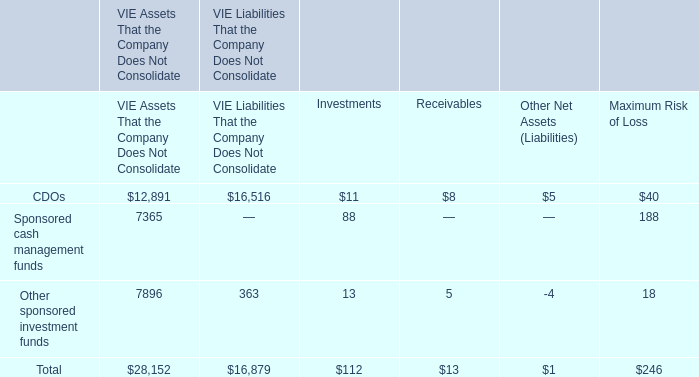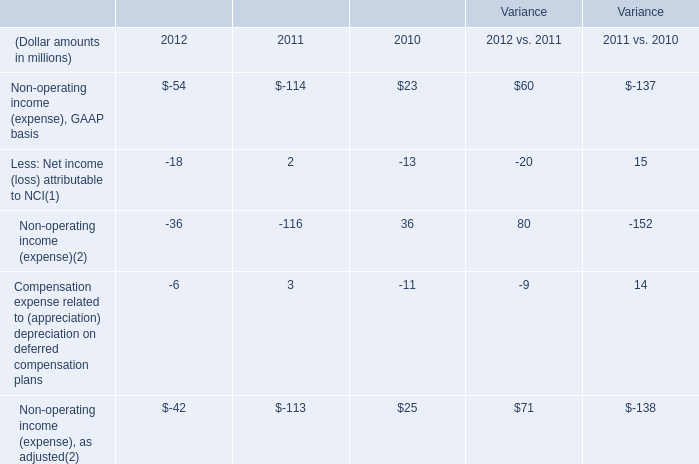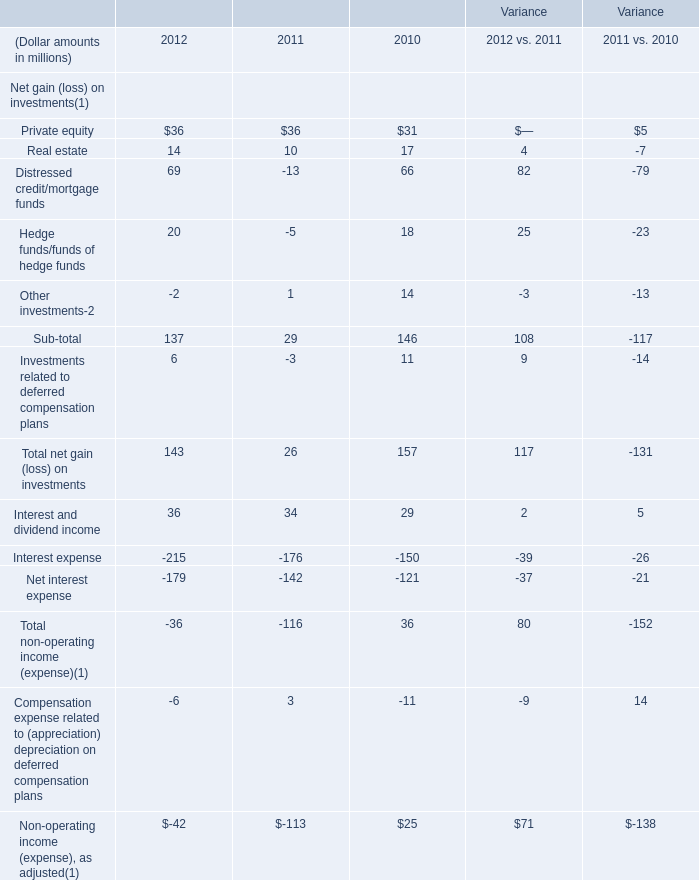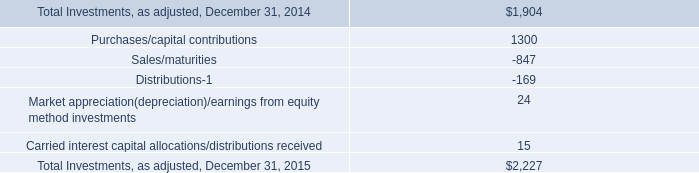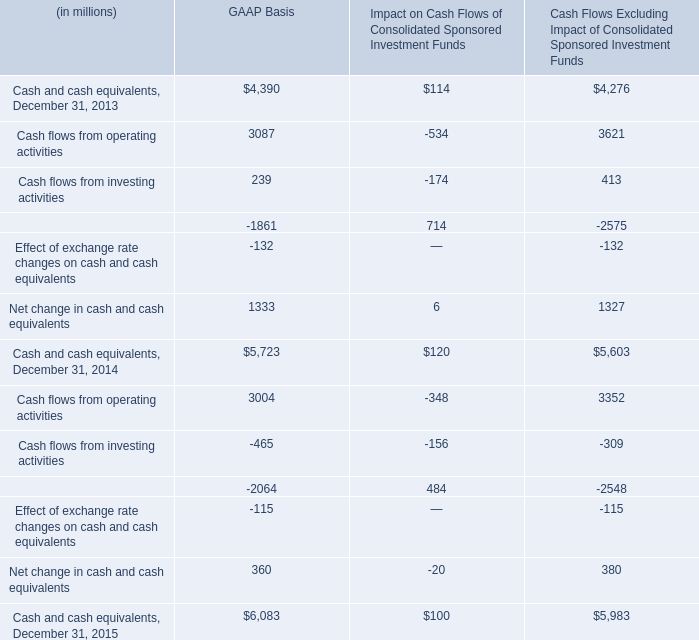What's the total amount of Private equity, Real estate, Distressed credit/mortgage funds and Hedge funds/funds of hedge funds in 2012? (in million) 
Computations: (((36 + 14) + 69) + 20)
Answer: 139.0. 